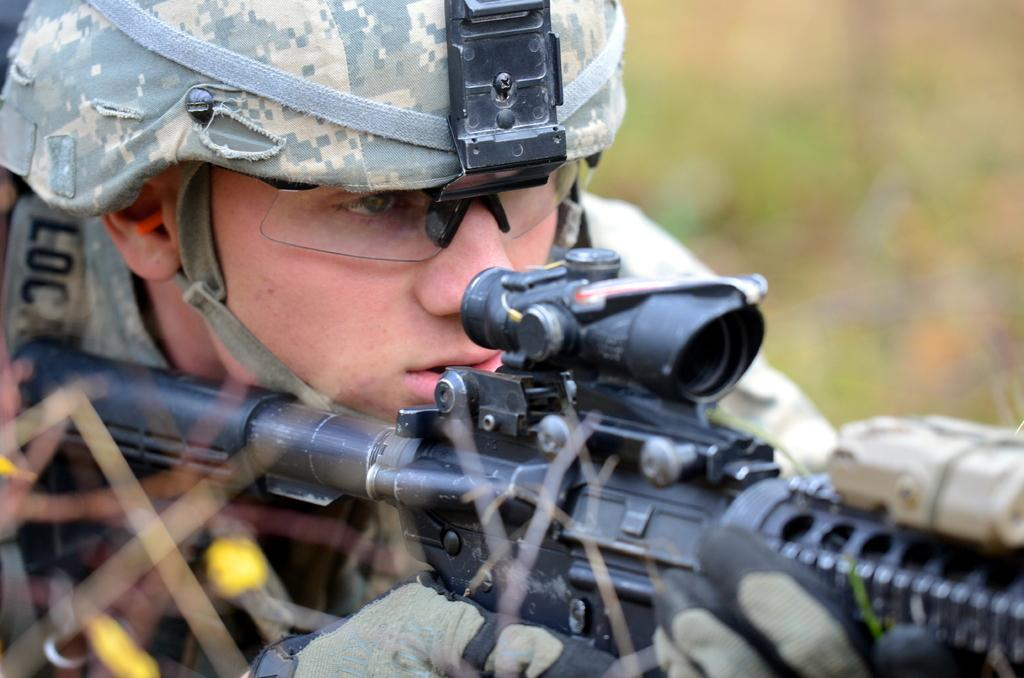What is the main subject of the image? There is a soldier in the image. What is the soldier holding in the image? The soldier is holding a gun. Can you describe the background of the image? The background of the image is blurred. What type of paper is the soldier using to write a letter in the image? There is no paper or letter-writing activity present in the image. The soldier is holding a gun, and the background is blurred. 